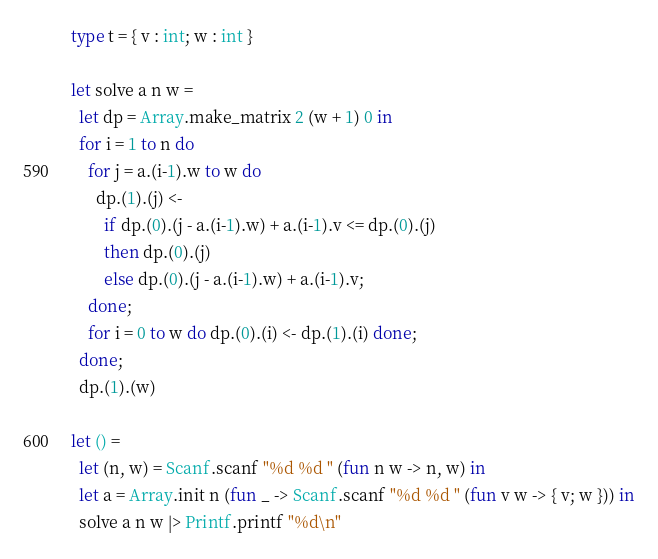<code> <loc_0><loc_0><loc_500><loc_500><_OCaml_>type t = { v : int; w : int }

let solve a n w =
  let dp = Array.make_matrix 2 (w + 1) 0 in
  for i = 1 to n do
    for j = a.(i-1).w to w do
      dp.(1).(j) <-
        if dp.(0).(j - a.(i-1).w) + a.(i-1).v <= dp.(0).(j)
        then dp.(0).(j)
        else dp.(0).(j - a.(i-1).w) + a.(i-1).v;
    done;
    for i = 0 to w do dp.(0).(i) <- dp.(1).(i) done;
  done;
  dp.(1).(w)

let () =
  let (n, w) = Scanf.scanf "%d %d " (fun n w -> n, w) in
  let a = Array.init n (fun _ -> Scanf.scanf "%d %d " (fun v w -> { v; w })) in
  solve a n w |> Printf.printf "%d\n"</code> 